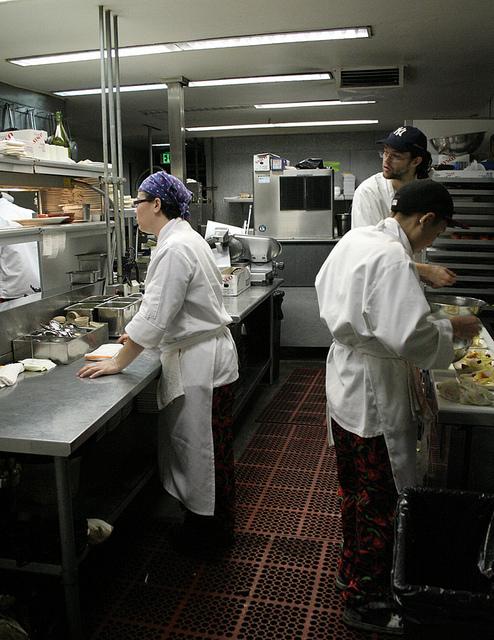What room is this?
Quick response, please. Kitchen. What kind of print is on the uniform pants?
Answer briefly. Spots. What is on the floor?
Short answer required. Mats. 